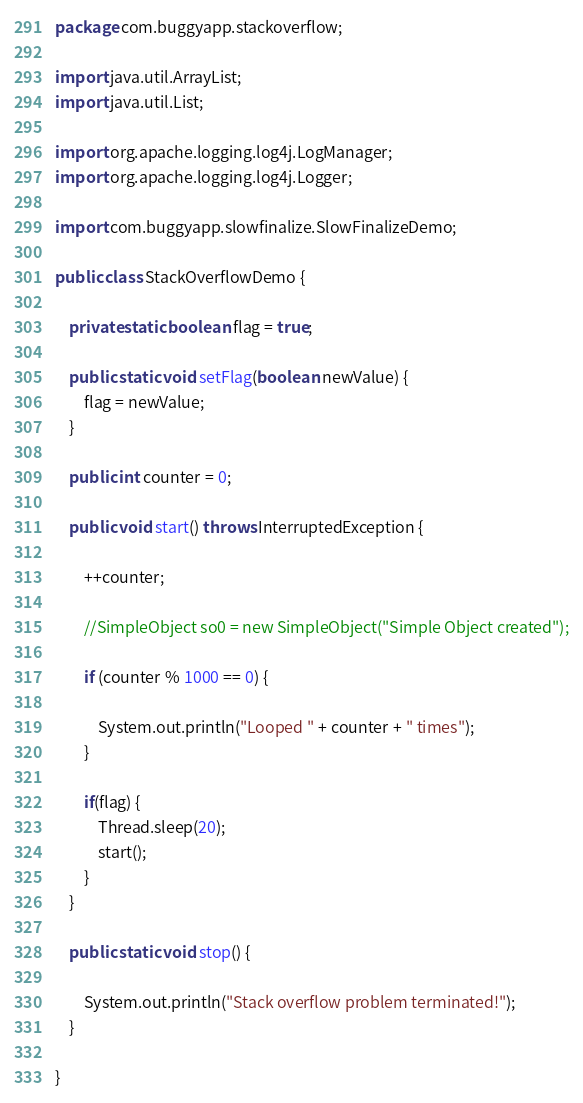Convert code to text. <code><loc_0><loc_0><loc_500><loc_500><_Java_>package com.buggyapp.stackoverflow;

import java.util.ArrayList;
import java.util.List;

import org.apache.logging.log4j.LogManager;
import org.apache.logging.log4j.Logger;

import com.buggyapp.slowfinalize.SlowFinalizeDemo;

public class StackOverflowDemo {

	private static boolean flag = true;
	
	public static void setFlag(boolean newValue) {
		flag = newValue;
	}
	
	public int counter = 0;
	
	public void start() throws InterruptedException {
		
		++counter;

		//SimpleObject so0 = new SimpleObject("Simple Object created");

		if (counter % 1000 == 0) {
			
			System.out.println("Looped " + counter + " times");
		}
		
		if(flag) {
			Thread.sleep(20);
			start();
		}
	}
	
	public static void stop() {
		
		System.out.println("Stack overflow problem terminated!");
	}
	
}
</code> 